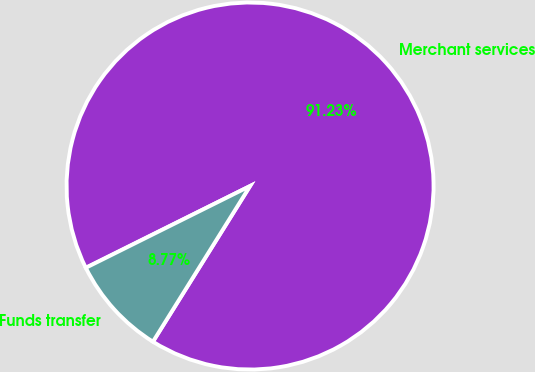Convert chart to OTSL. <chart><loc_0><loc_0><loc_500><loc_500><pie_chart><fcel>Merchant services<fcel>Funds transfer<nl><fcel>91.23%<fcel>8.77%<nl></chart> 